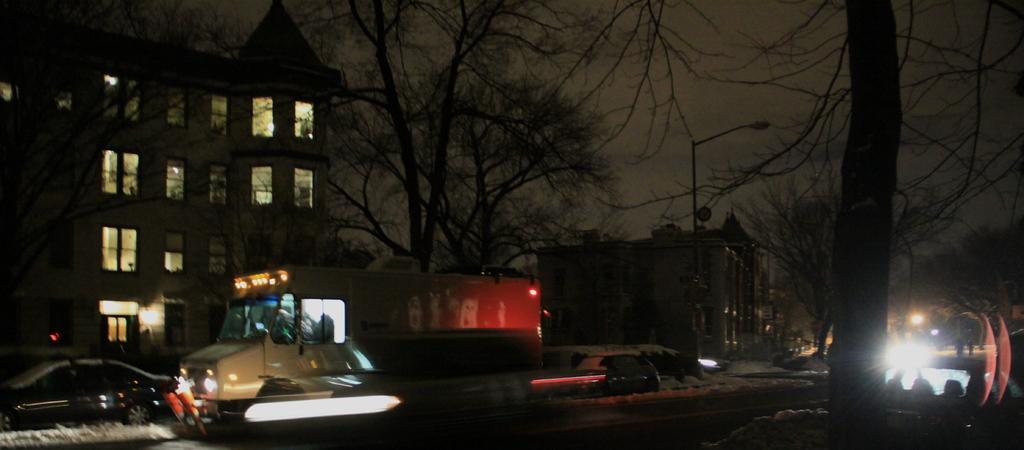In one or two sentences, can you explain what this image depicts? In this image there are vehicles on the road. Right side there is a street light. Background there are trees and buildings. Top of the image there is sky. 